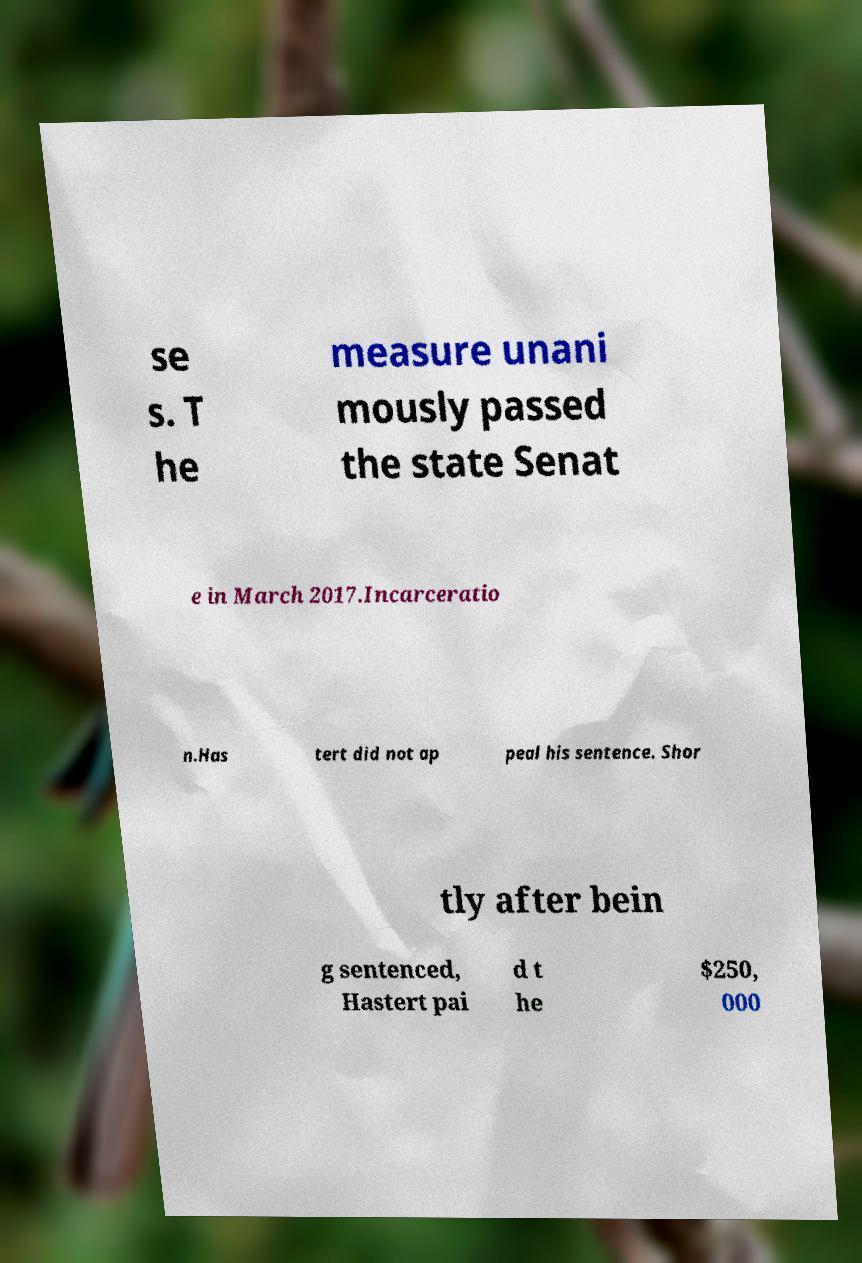Can you read and provide the text displayed in the image?This photo seems to have some interesting text. Can you extract and type it out for me? se s. T he measure unani mously passed the state Senat e in March 2017.Incarceratio n.Has tert did not ap peal his sentence. Shor tly after bein g sentenced, Hastert pai d t he $250, 000 